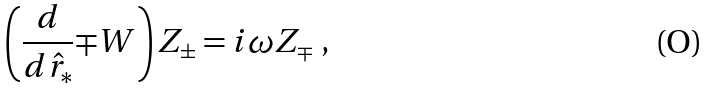Convert formula to latex. <formula><loc_0><loc_0><loc_500><loc_500>\left ( \frac { d } { d \hat { r } _ { * } } { \mp } W \right ) Z _ { \pm } = i \omega { Z _ { \mp } } \ ,</formula> 